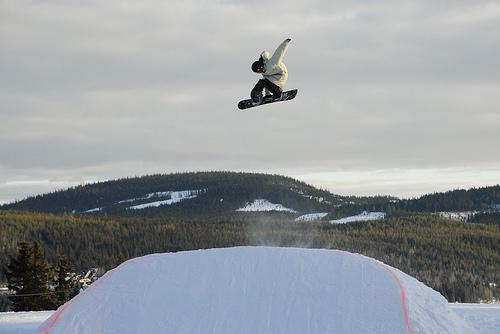Question: when is this picture taken?
Choices:
A. A parade.
B. Graduation.
C. Family reunion.
D. Competition.
Answer with the letter. Answer: D Question: who is pictured?
Choices:
A. Children.
B. Two women.
C. Coworkers.
D. Man.
Answer with the letter. Answer: D Question: where is this picture taken?
Choices:
A. Beach.
B. Grassy field.
C. Snow hill.
D. Campsite.
Answer with the letter. Answer: C Question: what color are the lines on the snow?
Choices:
A. Yellow.
B. Black.
C. Pink.
D. Blue.
Answer with the letter. Answer: C Question: why is the man in the air?
Choices:
A. Jumping up.
B. Floating.
C. Wearing a jetpack.
D. Doing a trick.
Answer with the letter. Answer: D Question: what is in the far distance?
Choices:
A. Birds.
B. Tanks.
C. A rainstorm.
D. Mountains.
Answer with the letter. Answer: D 